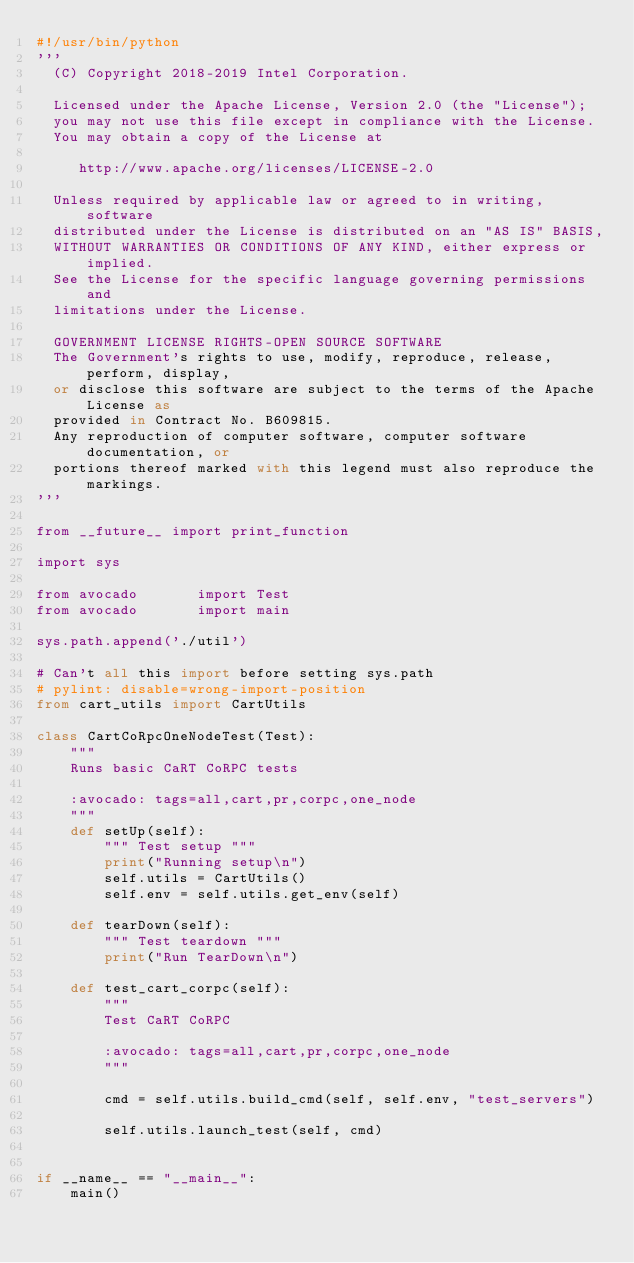<code> <loc_0><loc_0><loc_500><loc_500><_Python_>#!/usr/bin/python
'''
  (C) Copyright 2018-2019 Intel Corporation.

  Licensed under the Apache License, Version 2.0 (the "License");
  you may not use this file except in compliance with the License.
  You may obtain a copy of the License at

     http://www.apache.org/licenses/LICENSE-2.0

  Unless required by applicable law or agreed to in writing, software
  distributed under the License is distributed on an "AS IS" BASIS,
  WITHOUT WARRANTIES OR CONDITIONS OF ANY KIND, either express or implied.
  See the License for the specific language governing permissions and
  limitations under the License.

  GOVERNMENT LICENSE RIGHTS-OPEN SOURCE SOFTWARE
  The Government's rights to use, modify, reproduce, release, perform, display,
  or disclose this software are subject to the terms of the Apache License as
  provided in Contract No. B609815.
  Any reproduction of computer software, computer software documentation, or
  portions thereof marked with this legend must also reproduce the markings.
'''

from __future__ import print_function

import sys

from avocado       import Test
from avocado       import main

sys.path.append('./util')

# Can't all this import before setting sys.path
# pylint: disable=wrong-import-position
from cart_utils import CartUtils

class CartCoRpcOneNodeTest(Test):
    """
    Runs basic CaRT CoRPC tests

    :avocado: tags=all,cart,pr,corpc,one_node
    """
    def setUp(self):
        """ Test setup """
        print("Running setup\n")
        self.utils = CartUtils()
        self.env = self.utils.get_env(self)

    def tearDown(self):
        """ Test teardown """
        print("Run TearDown\n")

    def test_cart_corpc(self):
        """
        Test CaRT CoRPC

        :avocado: tags=all,cart,pr,corpc,one_node
        """

        cmd = self.utils.build_cmd(self, self.env, "test_servers")

        self.utils.launch_test(self, cmd)


if __name__ == "__main__":
    main()
</code> 